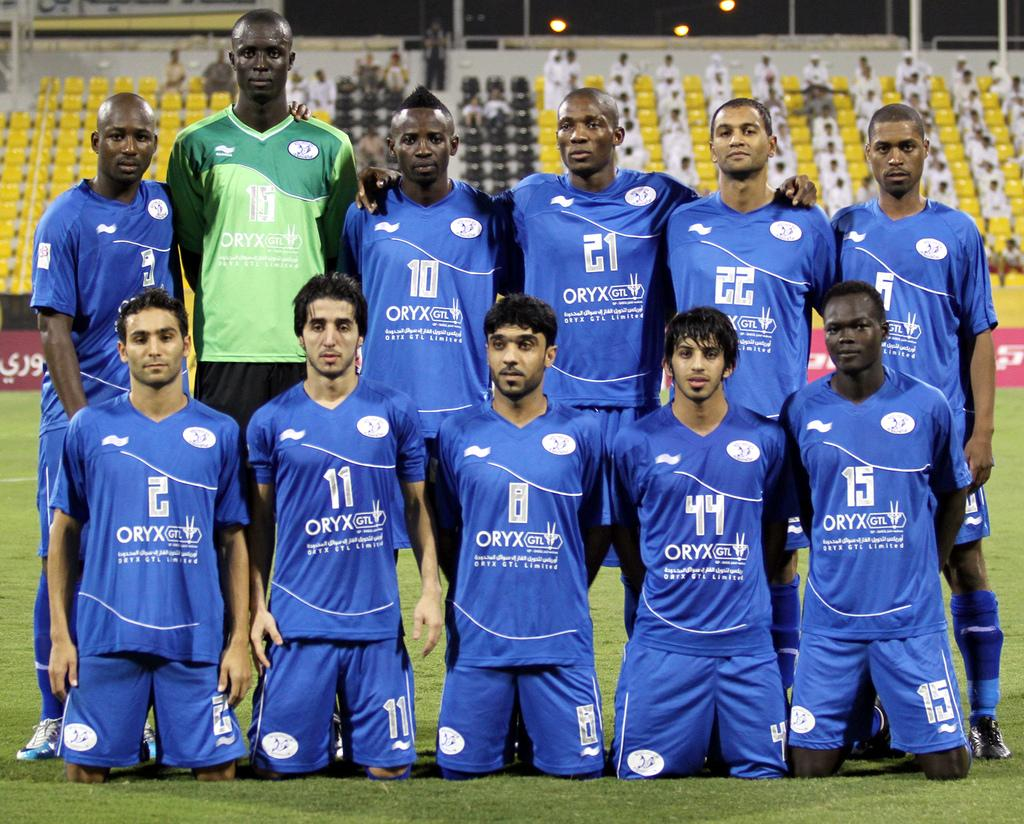<image>
Summarize the visual content of the image. Several teammates with the name ORYX on their jersey's are standing and kneeling on a field for a photo shoot. 